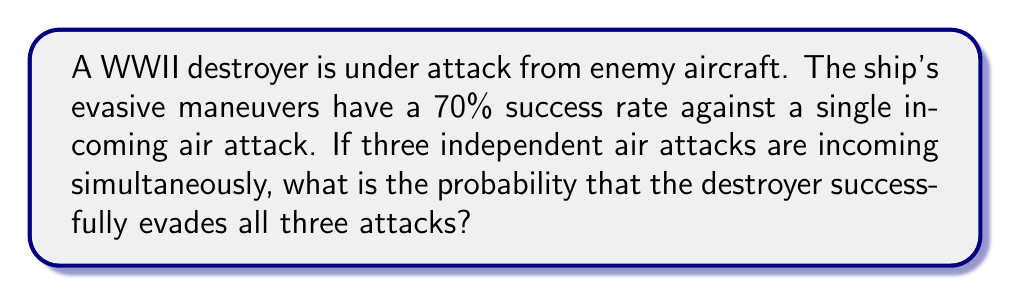Show me your answer to this math problem. To solve this problem, we'll use the concept of independent events and probability multiplication.

Step 1: Identify the probability of success for a single evasive maneuver.
$P(\text{single success}) = 0.70$ or $70\%$

Step 2: Recognize that we need all three evasive maneuvers to be successful, and they are independent events.

Step 3: Use the multiplication rule of probability for independent events. The probability of all three events occurring is the product of their individual probabilities.

$$P(\text{all three successful}) = P(\text{success}_1) \times P(\text{success}_2) \times P(\text{success}_3)$$

Step 4: Substitute the known probability for each event.

$$P(\text{all three successful}) = 0.70 \times 0.70 \times 0.70$$

Step 5: Calculate the final probability.

$$P(\text{all three successful}) = 0.70^3 = 0.343$$

Step 6: Convert to a percentage.

$$P(\text{all three successful}) = 0.343 \times 100\% = 34.3\%$$

Therefore, the probability that the destroyer successfully evades all three attacks is approximately 34.3%.
Answer: $34.3\%$ 